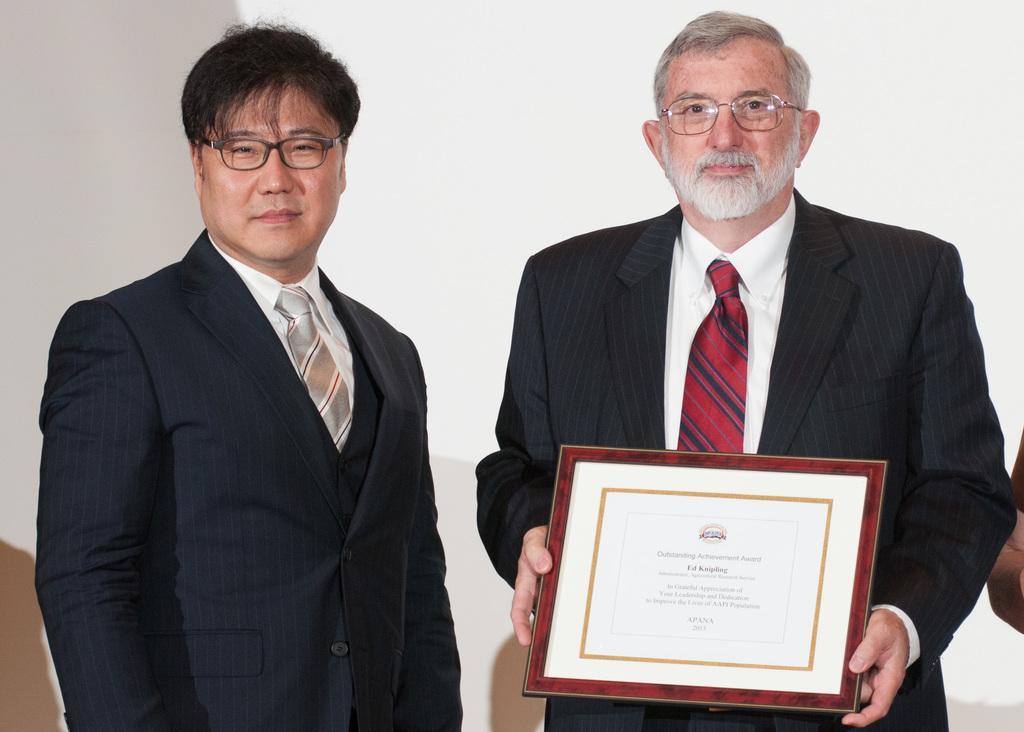In one or two sentences, can you explain what this image depicts? In this picture we can see two persons, among them we can see one person is holding shield. 